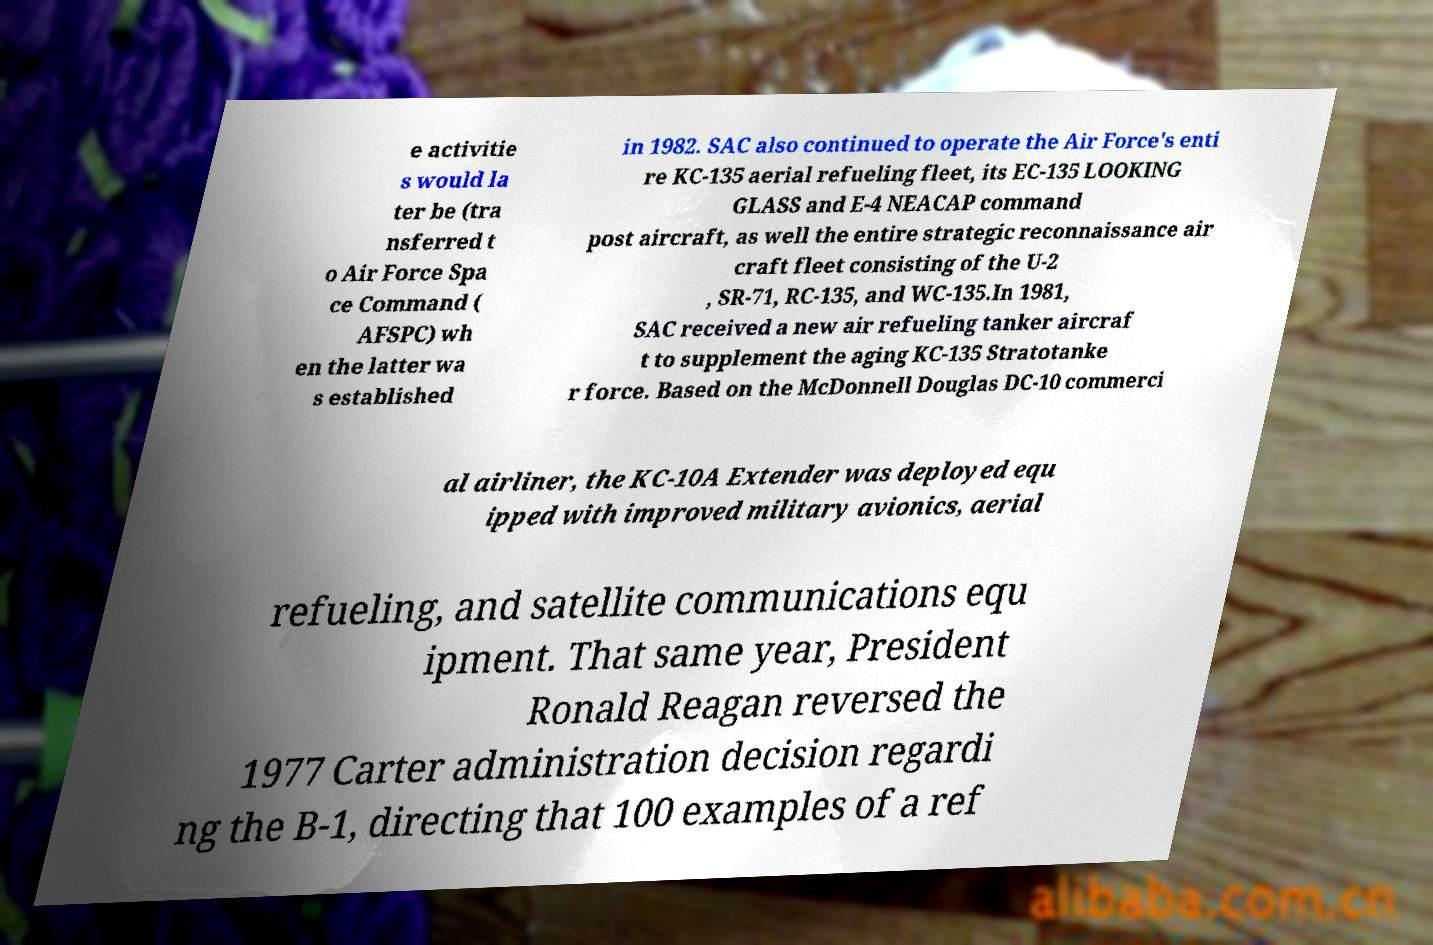What messages or text are displayed in this image? I need them in a readable, typed format. e activitie s would la ter be (tra nsferred t o Air Force Spa ce Command ( AFSPC) wh en the latter wa s established in 1982. SAC also continued to operate the Air Force's enti re KC-135 aerial refueling fleet, its EC-135 LOOKING GLASS and E-4 NEACAP command post aircraft, as well the entire strategic reconnaissance air craft fleet consisting of the U-2 , SR-71, RC-135, and WC-135.In 1981, SAC received a new air refueling tanker aircraf t to supplement the aging KC-135 Stratotanke r force. Based on the McDonnell Douglas DC-10 commerci al airliner, the KC-10A Extender was deployed equ ipped with improved military avionics, aerial refueling, and satellite communications equ ipment. That same year, President Ronald Reagan reversed the 1977 Carter administration decision regardi ng the B-1, directing that 100 examples of a ref 